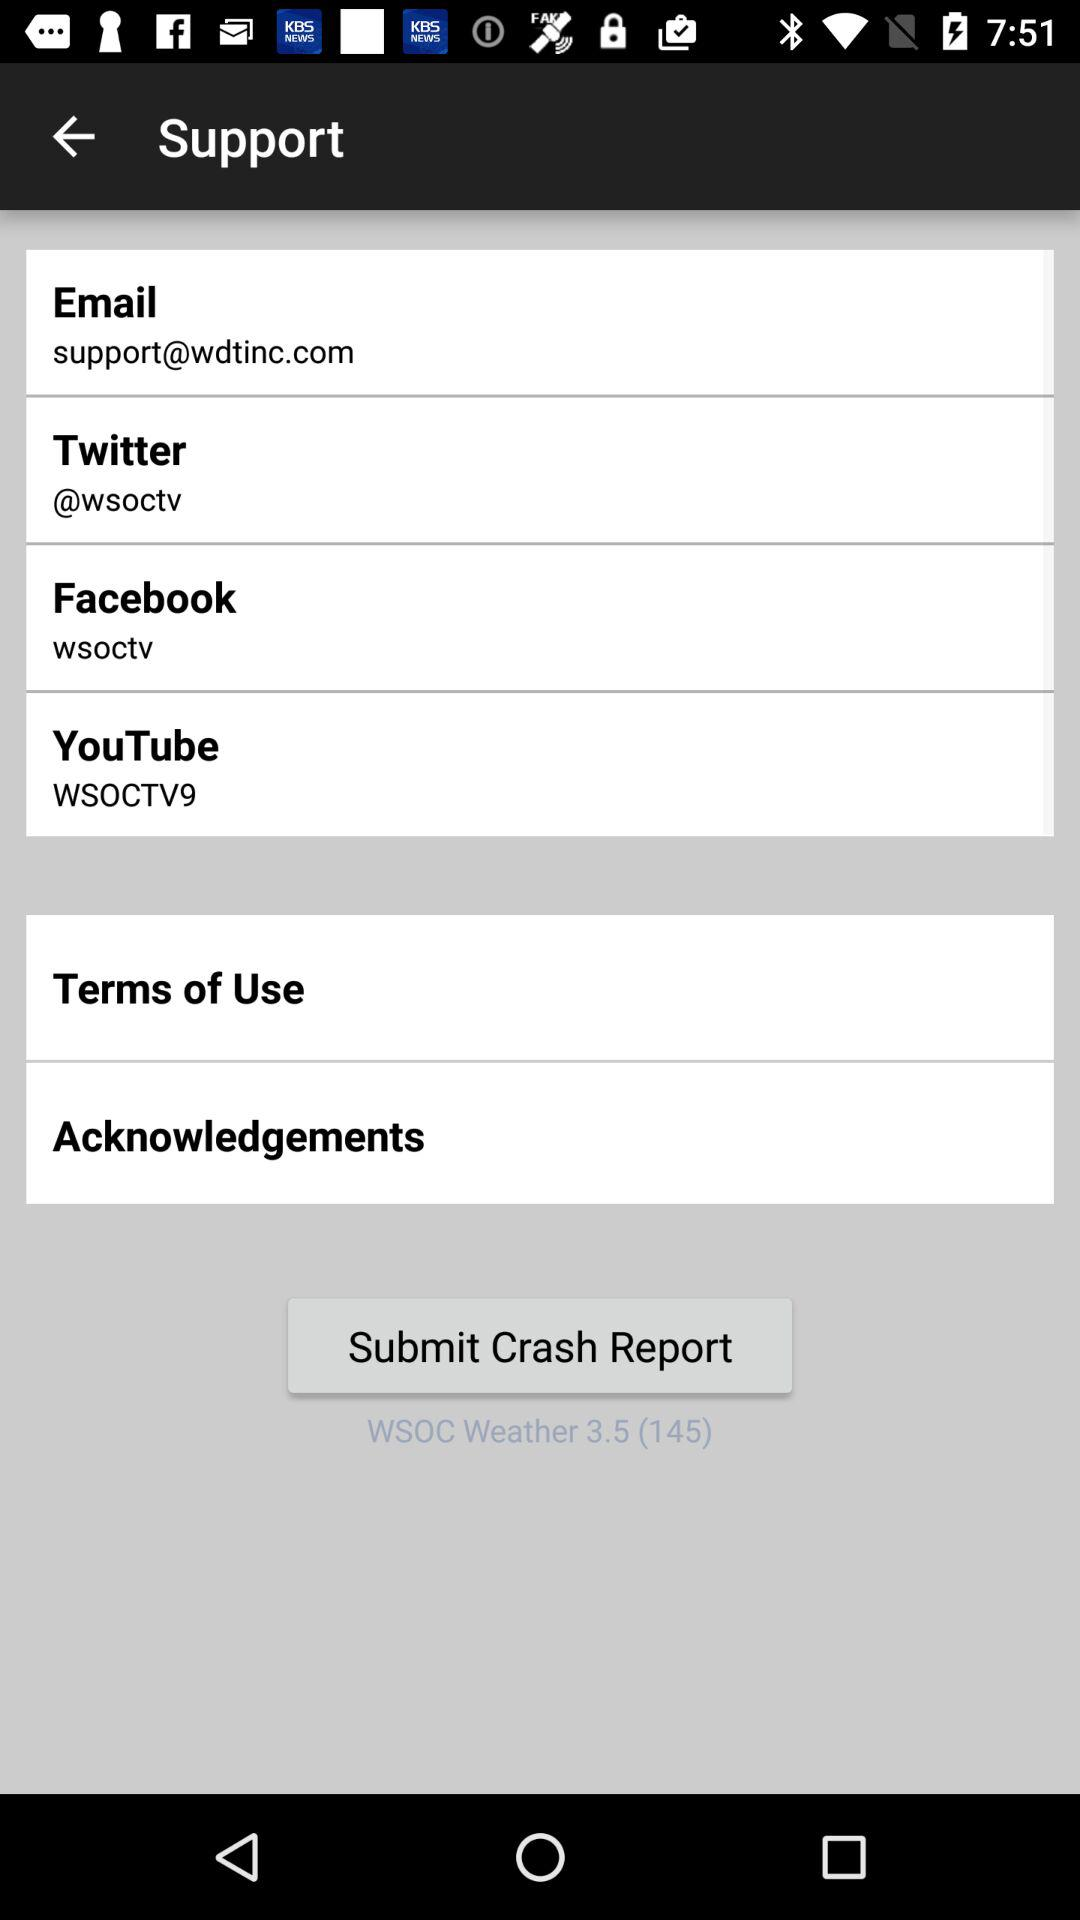What is the support email address? The support email address is support@wdtinc.com. 